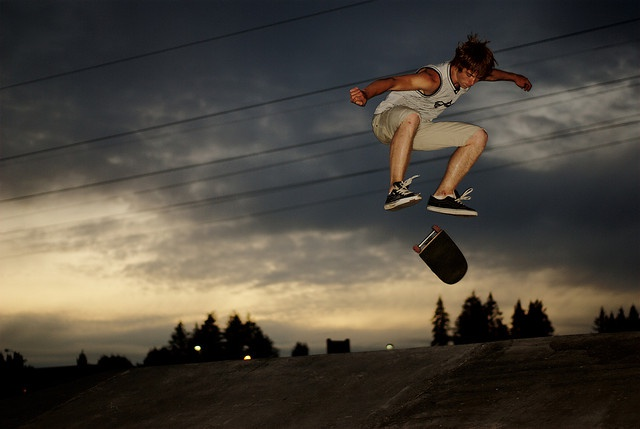Describe the objects in this image and their specific colors. I can see people in black, tan, maroon, and gray tones and skateboard in black, maroon, and gray tones in this image. 